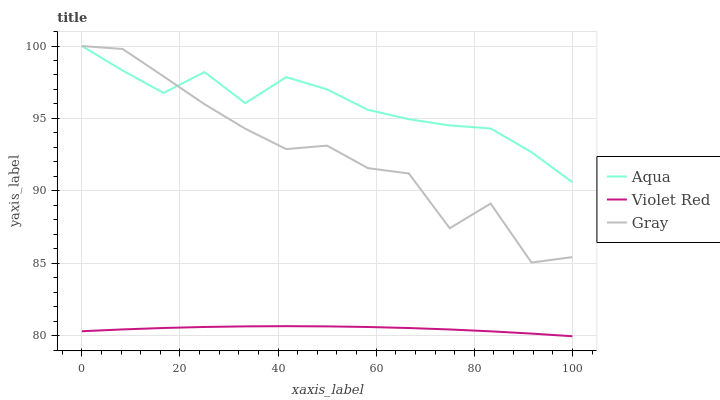Does Violet Red have the minimum area under the curve?
Answer yes or no. Yes. Does Aqua have the maximum area under the curve?
Answer yes or no. Yes. Does Aqua have the minimum area under the curve?
Answer yes or no. No. Does Violet Red have the maximum area under the curve?
Answer yes or no. No. Is Violet Red the smoothest?
Answer yes or no. Yes. Is Gray the roughest?
Answer yes or no. Yes. Is Aqua the smoothest?
Answer yes or no. No. Is Aqua the roughest?
Answer yes or no. No. Does Violet Red have the lowest value?
Answer yes or no. Yes. Does Aqua have the lowest value?
Answer yes or no. No. Does Aqua have the highest value?
Answer yes or no. Yes. Does Violet Red have the highest value?
Answer yes or no. No. Is Violet Red less than Aqua?
Answer yes or no. Yes. Is Aqua greater than Violet Red?
Answer yes or no. Yes. Does Gray intersect Aqua?
Answer yes or no. Yes. Is Gray less than Aqua?
Answer yes or no. No. Is Gray greater than Aqua?
Answer yes or no. No. Does Violet Red intersect Aqua?
Answer yes or no. No. 